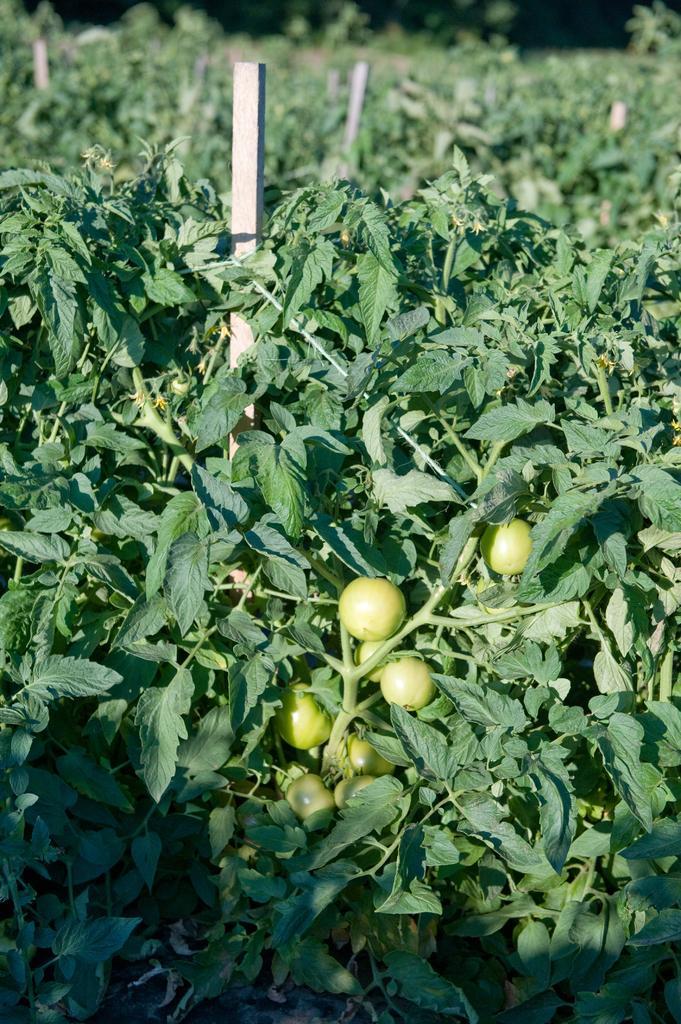Could you give a brief overview of what you see in this image? In this image we can see many plants. There are few fruits in the image. There are few objects in the image. 